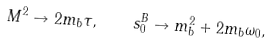Convert formula to latex. <formula><loc_0><loc_0><loc_500><loc_500>M ^ { 2 } \to 2 m _ { b } \tau , \quad s _ { 0 } ^ { B } \to m _ { b } ^ { 2 } + 2 m _ { b } \omega _ { 0 } ,</formula> 